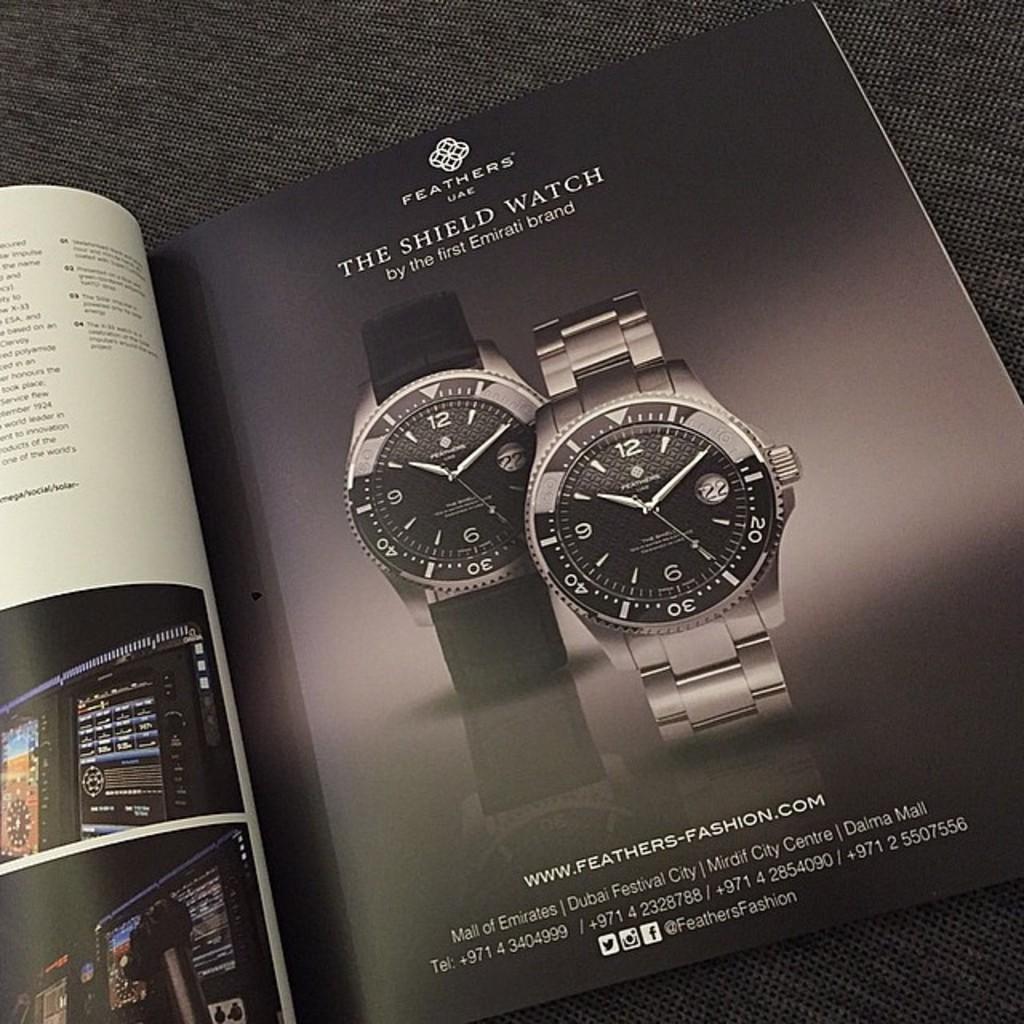What is the brand name of this watch?
Provide a short and direct response. Feathers. 